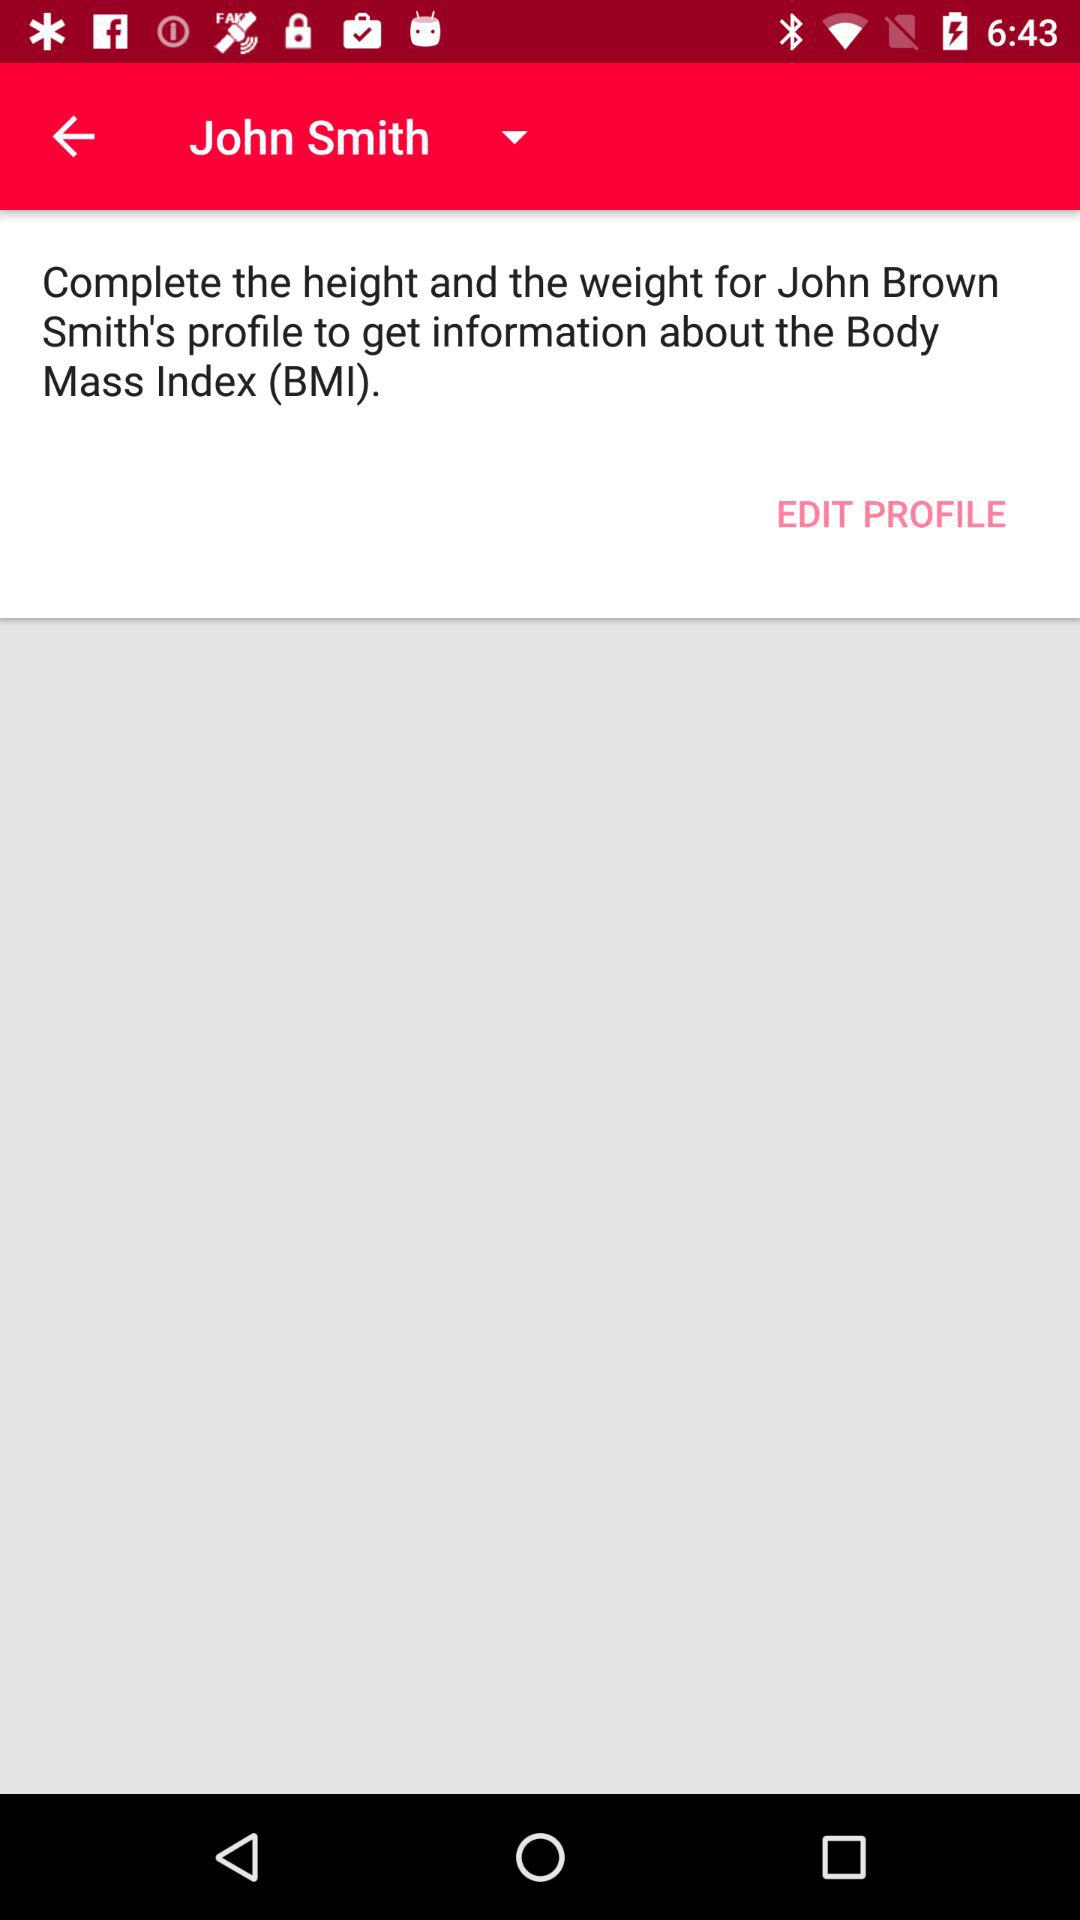What is the name of the user whose BMI is to be calculated? The name of the user is John Smith. 